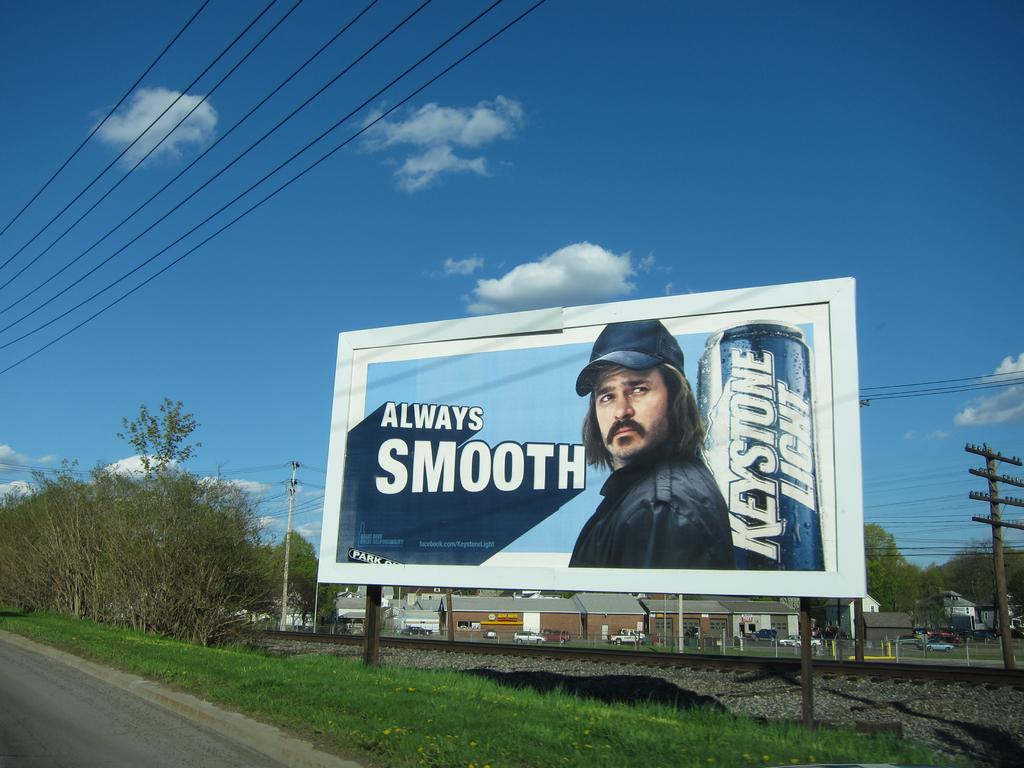<image>
Provide a brief description of the given image. a billboard for Keystone Light says it is Always Smooth 